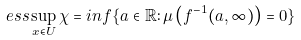Convert formula to latex. <formula><loc_0><loc_0><loc_500><loc_500>e s s \sup _ { x \in U } \chi = i n f \{ a \in \mathbb { R } \colon \mu \left ( f ^ { - 1 } ( a , \infty ) \right ) = 0 \}</formula> 